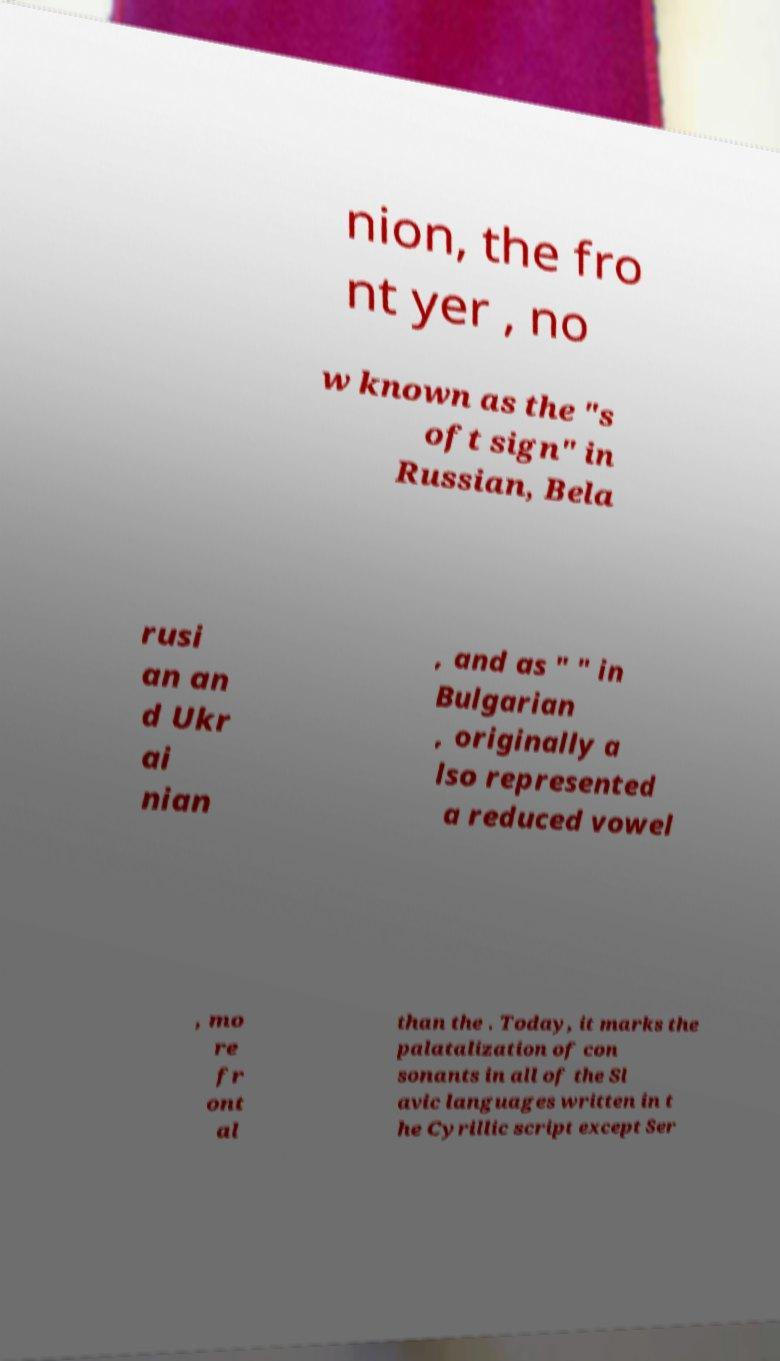There's text embedded in this image that I need extracted. Can you transcribe it verbatim? nion, the fro nt yer , no w known as the "s oft sign" in Russian, Bela rusi an an d Ukr ai nian , and as " " in Bulgarian , originally a lso represented a reduced vowel , mo re fr ont al than the . Today, it marks the palatalization of con sonants in all of the Sl avic languages written in t he Cyrillic script except Ser 